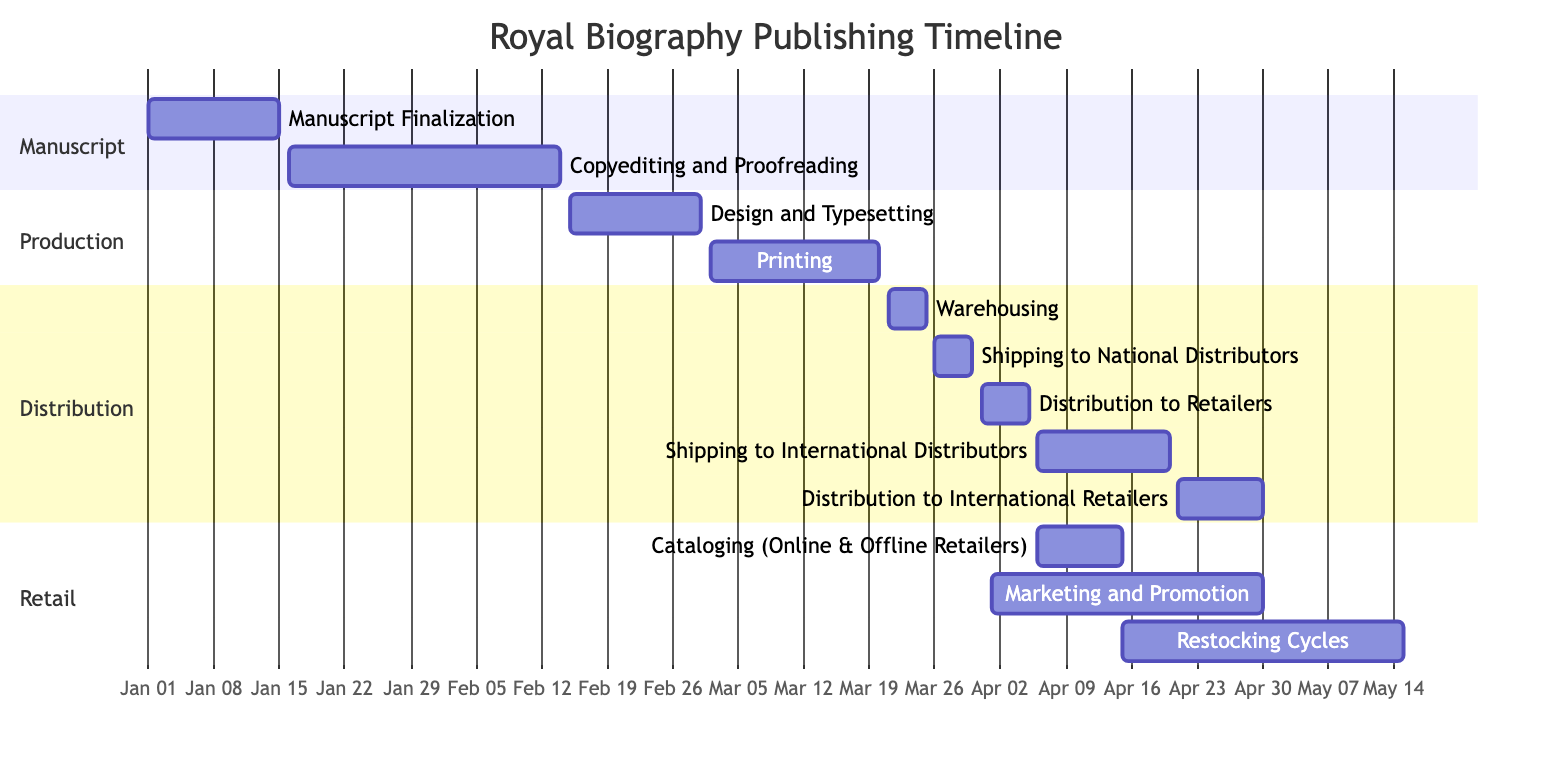What is the duration of the Printing task? The Printing task starts on March 2, 2023, and ends on March 20, 2023. The duration can be calculated by finding the difference between these two dates, which is 19 days.
Answer: 19 days How many tasks are in the Production section? The Production section includes three tasks: Design and Typesetting, Printing, and Warehousing. Counting these tasks gives a total of three in this section.
Answer: 3 What is the start date for Distribution to Retailers? The Distribution to Retailers task starts on March 31, 2023, as indicated in the diagram.
Answer: March 31, 2023 Which task overlaps with Shipping to International Distributors? Shipping to International Distributors runs from April 6, 2023, to April 20, 2023. The tasks that overlap with it during this period are Cataloging (Online & Offline Retailers) and Distribution to Retailers. Analyzing the timeline, both of these tasks fall within the timeframe of Shipping to International Distributors.
Answer: Cataloging and Distribution to Retailers What is the last task to be completed? The last task in the timeline is Restocking Cycles, which ends on May 15, 2023. Looking at the end dates of all tasks, this task has the furthest completion date.
Answer: Restocking Cycles Which evaluation stage occurs right after Warehousing? After the Warehousing task, the next task is Shipping to National Distributors, which begins immediately after Warehousing ends on March 25, 2023. The flow of the tasks shows this direct succession.
Answer: Shipping to National Distributors How many days does Marketing and Promotion run? The Marketing and Promotion task starts on April 1, 2023, and ends on April 30, 2023. Calculating the days, we find that the duration of this task is 30 days.
Answer: 30 days What is the total number of tasks listed in the Gantt chart? By counting all the tasks presented in different sections of the chart (Manuscript, Production, Distribution, and Retail), we find there are 12 tasks in total across all sections.
Answer: 12 tasks Which task starts immediately after Copyediting and Proofreading? Following Copyediting and Proofreading, which ends on February 14, 2023, the next task is Design and Typesetting, starting on February 15, 2023. The timeline indicates this immediate succession clearly.
Answer: Design and Typesetting 